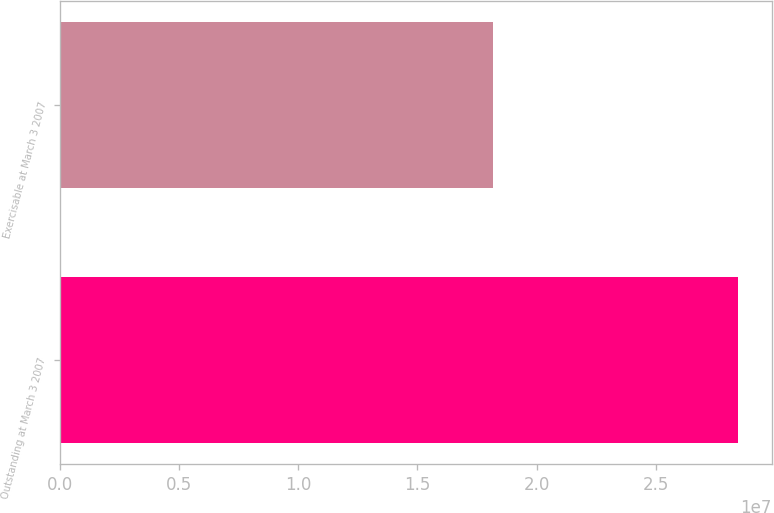Convert chart to OTSL. <chart><loc_0><loc_0><loc_500><loc_500><bar_chart><fcel>Outstanding at March 3 2007<fcel>Exercisable at March 3 2007<nl><fcel>2.8433e+07<fcel>1.8181e+07<nl></chart> 